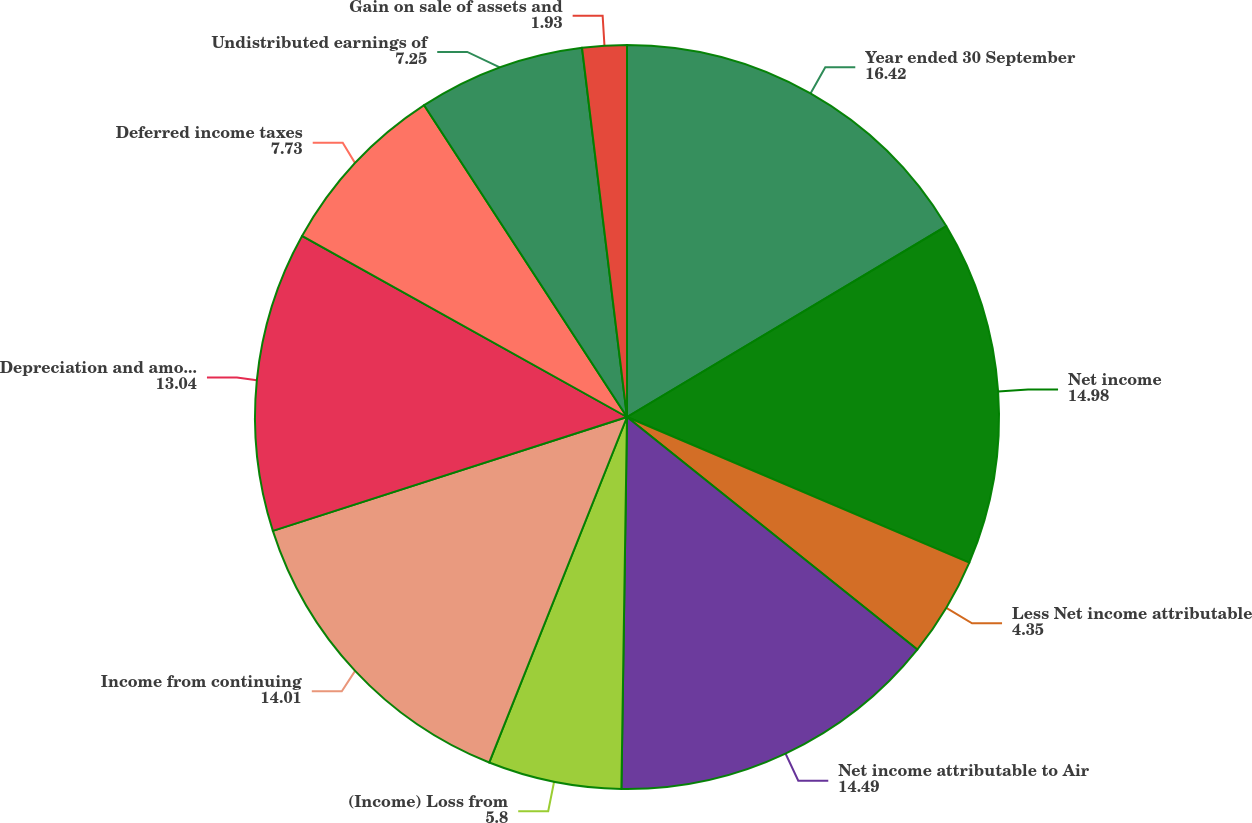<chart> <loc_0><loc_0><loc_500><loc_500><pie_chart><fcel>Year ended 30 September<fcel>Net income<fcel>Less Net income attributable<fcel>Net income attributable to Air<fcel>(Income) Loss from<fcel>Income from continuing<fcel>Depreciation and amortization<fcel>Deferred income taxes<fcel>Undistributed earnings of<fcel>Gain on sale of assets and<nl><fcel>16.42%<fcel>14.98%<fcel>4.35%<fcel>14.49%<fcel>5.8%<fcel>14.01%<fcel>13.04%<fcel>7.73%<fcel>7.25%<fcel>1.93%<nl></chart> 